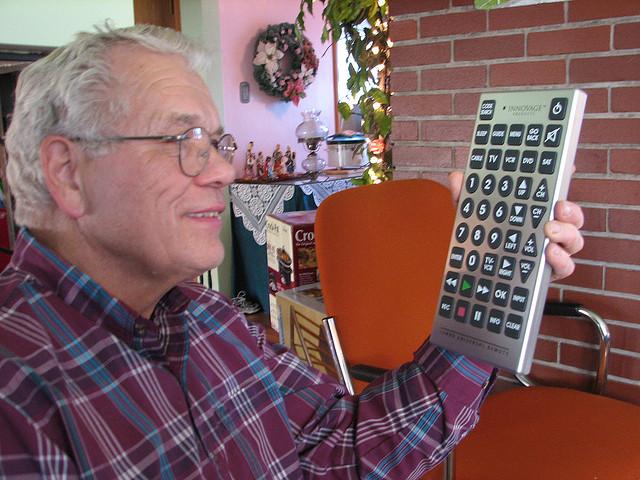Is the man wearing glasses?
Short answer required. Yes. What is the wall on the right made out of?
Concise answer only. Brick. What is the man holding?
Quick response, please. Remote control. 